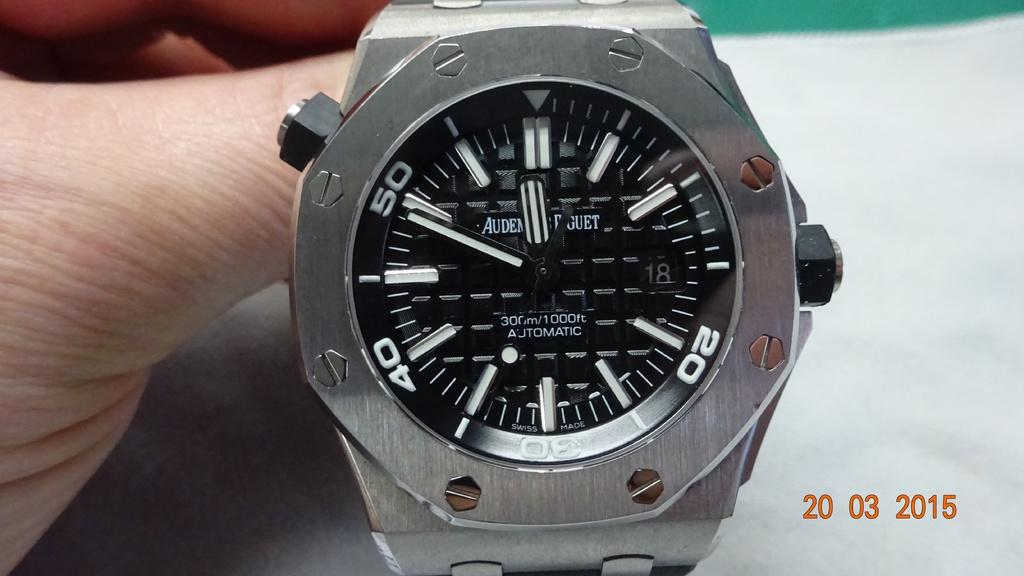Provide a one-sentence caption for the provided image. A watch with the number 20 on it being held up by a hand. 